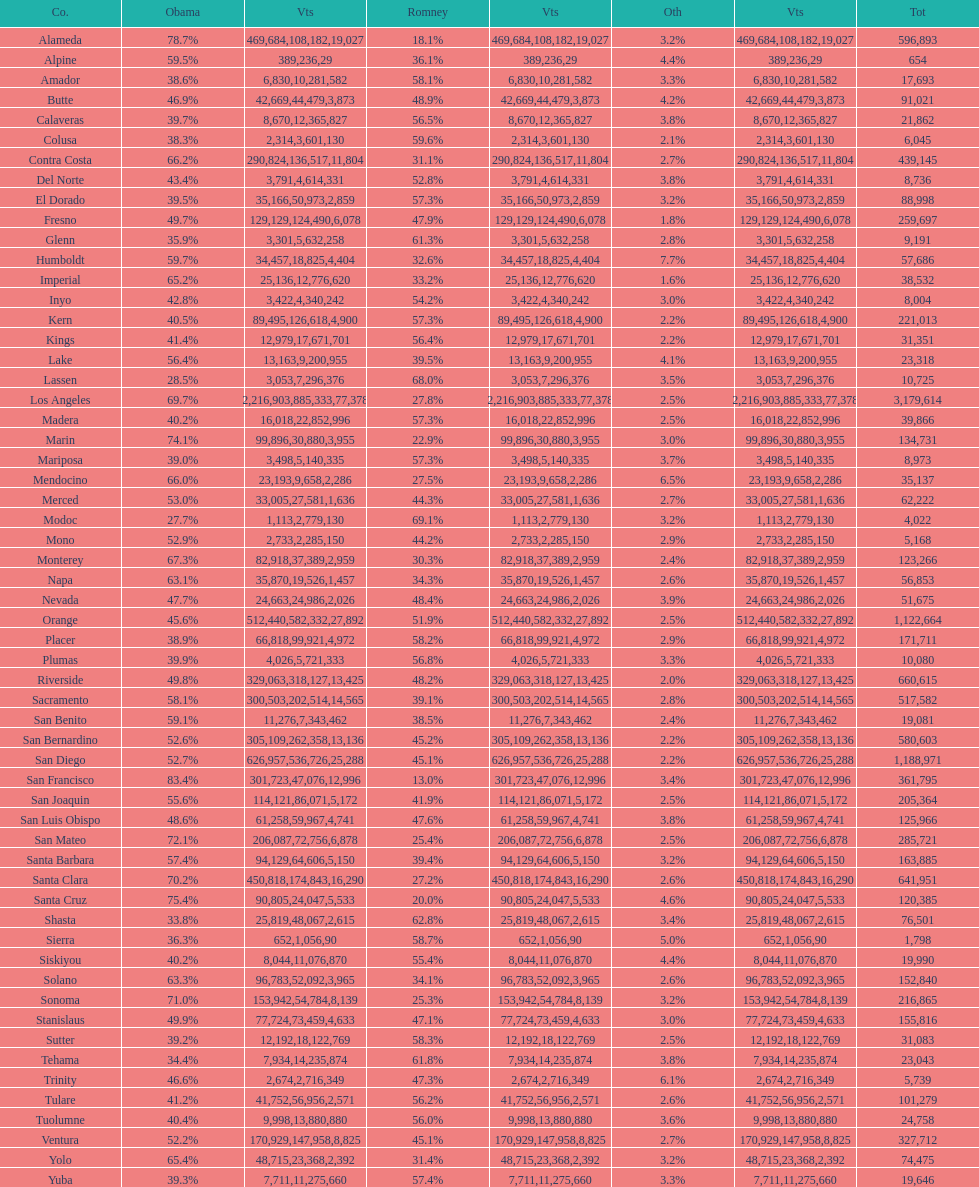Which county had the most total votes? Los Angeles. 